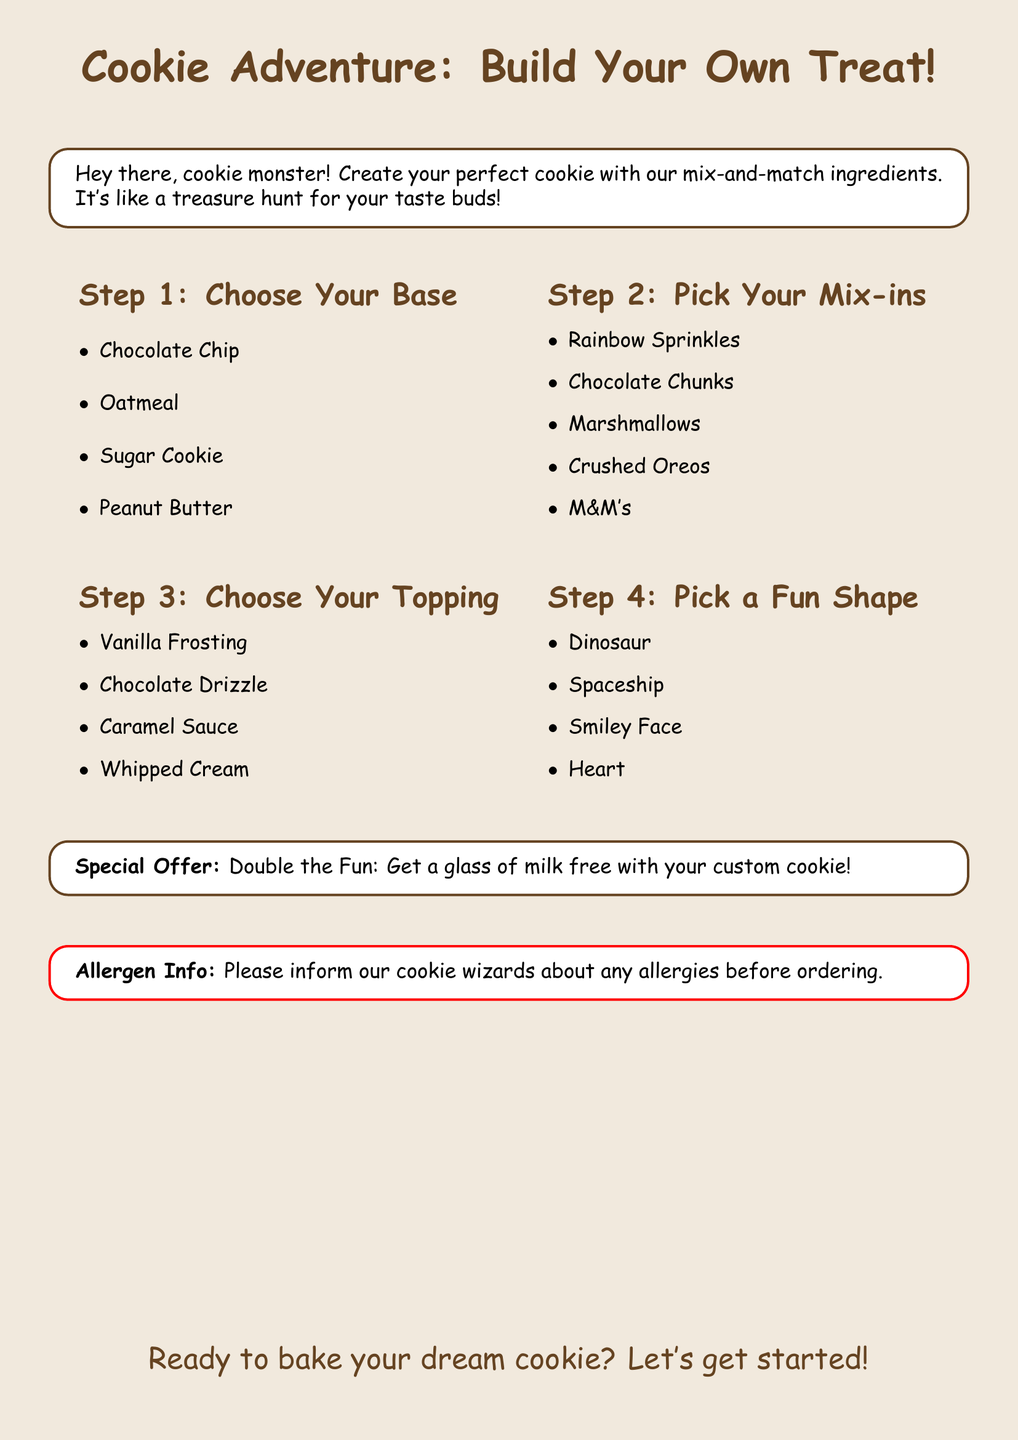What is the title of the cookie menu? The title is prominently displayed at the top of the document, indicating the theme of the cookie experience.
Answer: Cookie Adventure: Build Your Own Treat! How many steps are there to build your cookie? The document outlines four distinct steps that guide you through creating your cookie.
Answer: 4 What is the first step in building your cookie? The first step involves choosing the base for the cookie, which is essential to its foundation.
Answer: Choose Your Base Name one mix-in option available for cookies. The mix-ins are a key component that flavors the cookie, and several options are listed in the document.
Answer: Chocolate Chunks What free item is offered with the custom cookie? The document mentions a special offer that accompanies the creation of your cookie, adding value to the purchase.
Answer: glass of milk Which fun shape can you choose for your cookie? The shapes section includes playful options that can make the cookie more fun and visually appealing.
Answer: Smiley Face What color is used for the cookie theme in the document? The background color sets the tone for the document, creating a warm and inviting atmosphere.
Answer: cookiecolor What should you inform the staff about when ordering? The document includes an important note for customers regarding their health and safety while enjoying the cookies.
Answer: allergies 